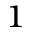<formula> <loc_0><loc_0><loc_500><loc_500>^ { 1 }</formula> 